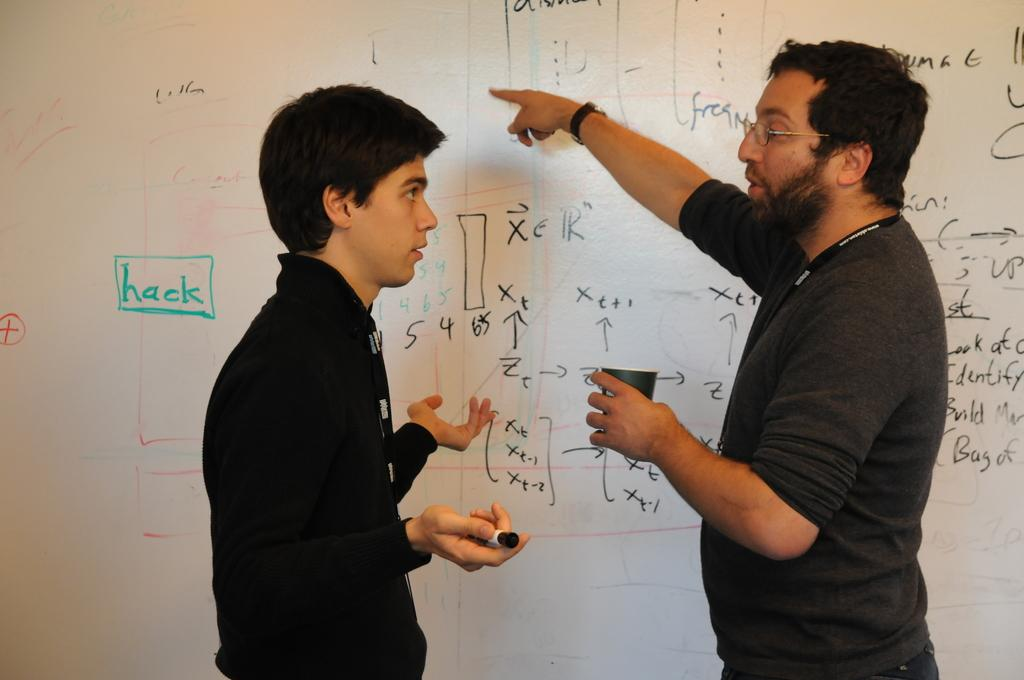<image>
Offer a succinct explanation of the picture presented. Two men in front of a white board with "hack" written in green. 